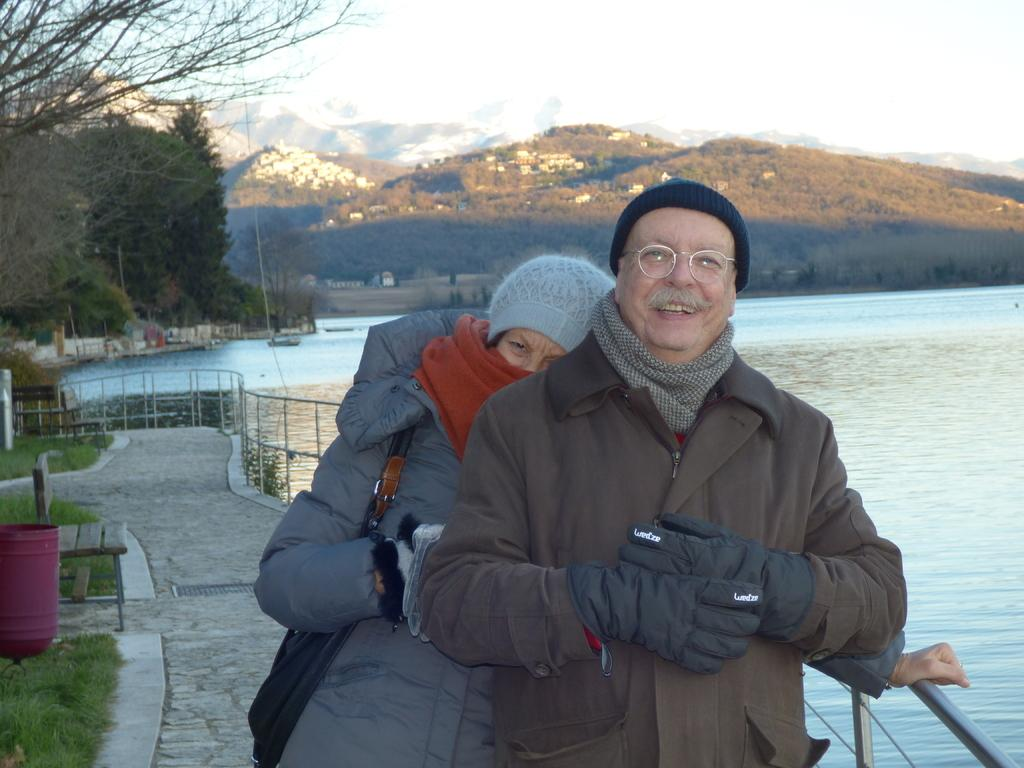How many people are in the image? There are two people in the image, a man and a woman. What are the man and woman doing in the image? The man and woman are standing together. What can be seen in the background of the image? There is water, trees, a fence, grass, a bench, mountains, and the sky visible in the background of the image. What type of gun is the man holding in the image? There is no gun present in the image; the man is not holding any object. How many cats can be seen playing with sugar in the image? There are no cats or sugar present in the image. 